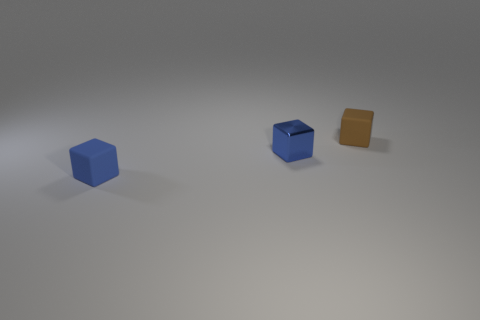Is the color of the small cube that is in front of the tiny metallic object the same as the metal block to the left of the brown object? yes 